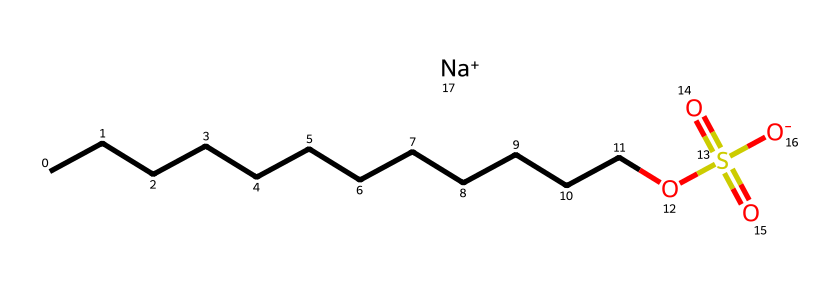What is the common name for this chemical? The SMILES provided corresponds to sodium lauryl sulfate, which is a well-known surfactant used in cleaning products.
Answer: sodium lauryl sulfate How many carbon atoms are in the structure? The chain of carbon atoms in the SMILES indicates there are 12 carbon atoms (CCCCCCCCCCCC) in total.
Answer: 12 What is the functional group present in this surfactant? The presence of the sulfonate group (OS(=O)(=O)[O-]) indicates the functional group of this chemical, which is characteristic of surfactants.
Answer: sulfonate What is the charge of the sodium ion in this chemical? The SMILES notation shows [Na+], indicating that the sodium ion has a positive charge.
Answer: positive Does this chemical have hydrophilic or lipophilic properties? The sulfonate group contributes to the hydrophilic nature, while the long carbon chain gives it lipophilic properties, making it amphiphilic.
Answer: amphiphilic What role does sodium lauryl sulfate play in cleaning products? As a surfactant, sodium lauryl sulfate reduces surface tension, allowing dirt and grease to be effectively emulsified and rinsed away.
Answer: surfactant What is the total number of oxygen atoms in this chemical structure? Analyzing the SMILES representation shows there are 4 oxygen atoms present in the sulfonate group and the hydroxyl group.
Answer: 4 